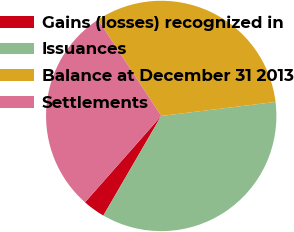Convert chart to OTSL. <chart><loc_0><loc_0><loc_500><loc_500><pie_chart><fcel>Gains (losses) recognized in<fcel>Issuances<fcel>Balance at December 31 2013<fcel>Settlements<nl><fcel>3.13%<fcel>35.32%<fcel>32.29%<fcel>29.26%<nl></chart> 